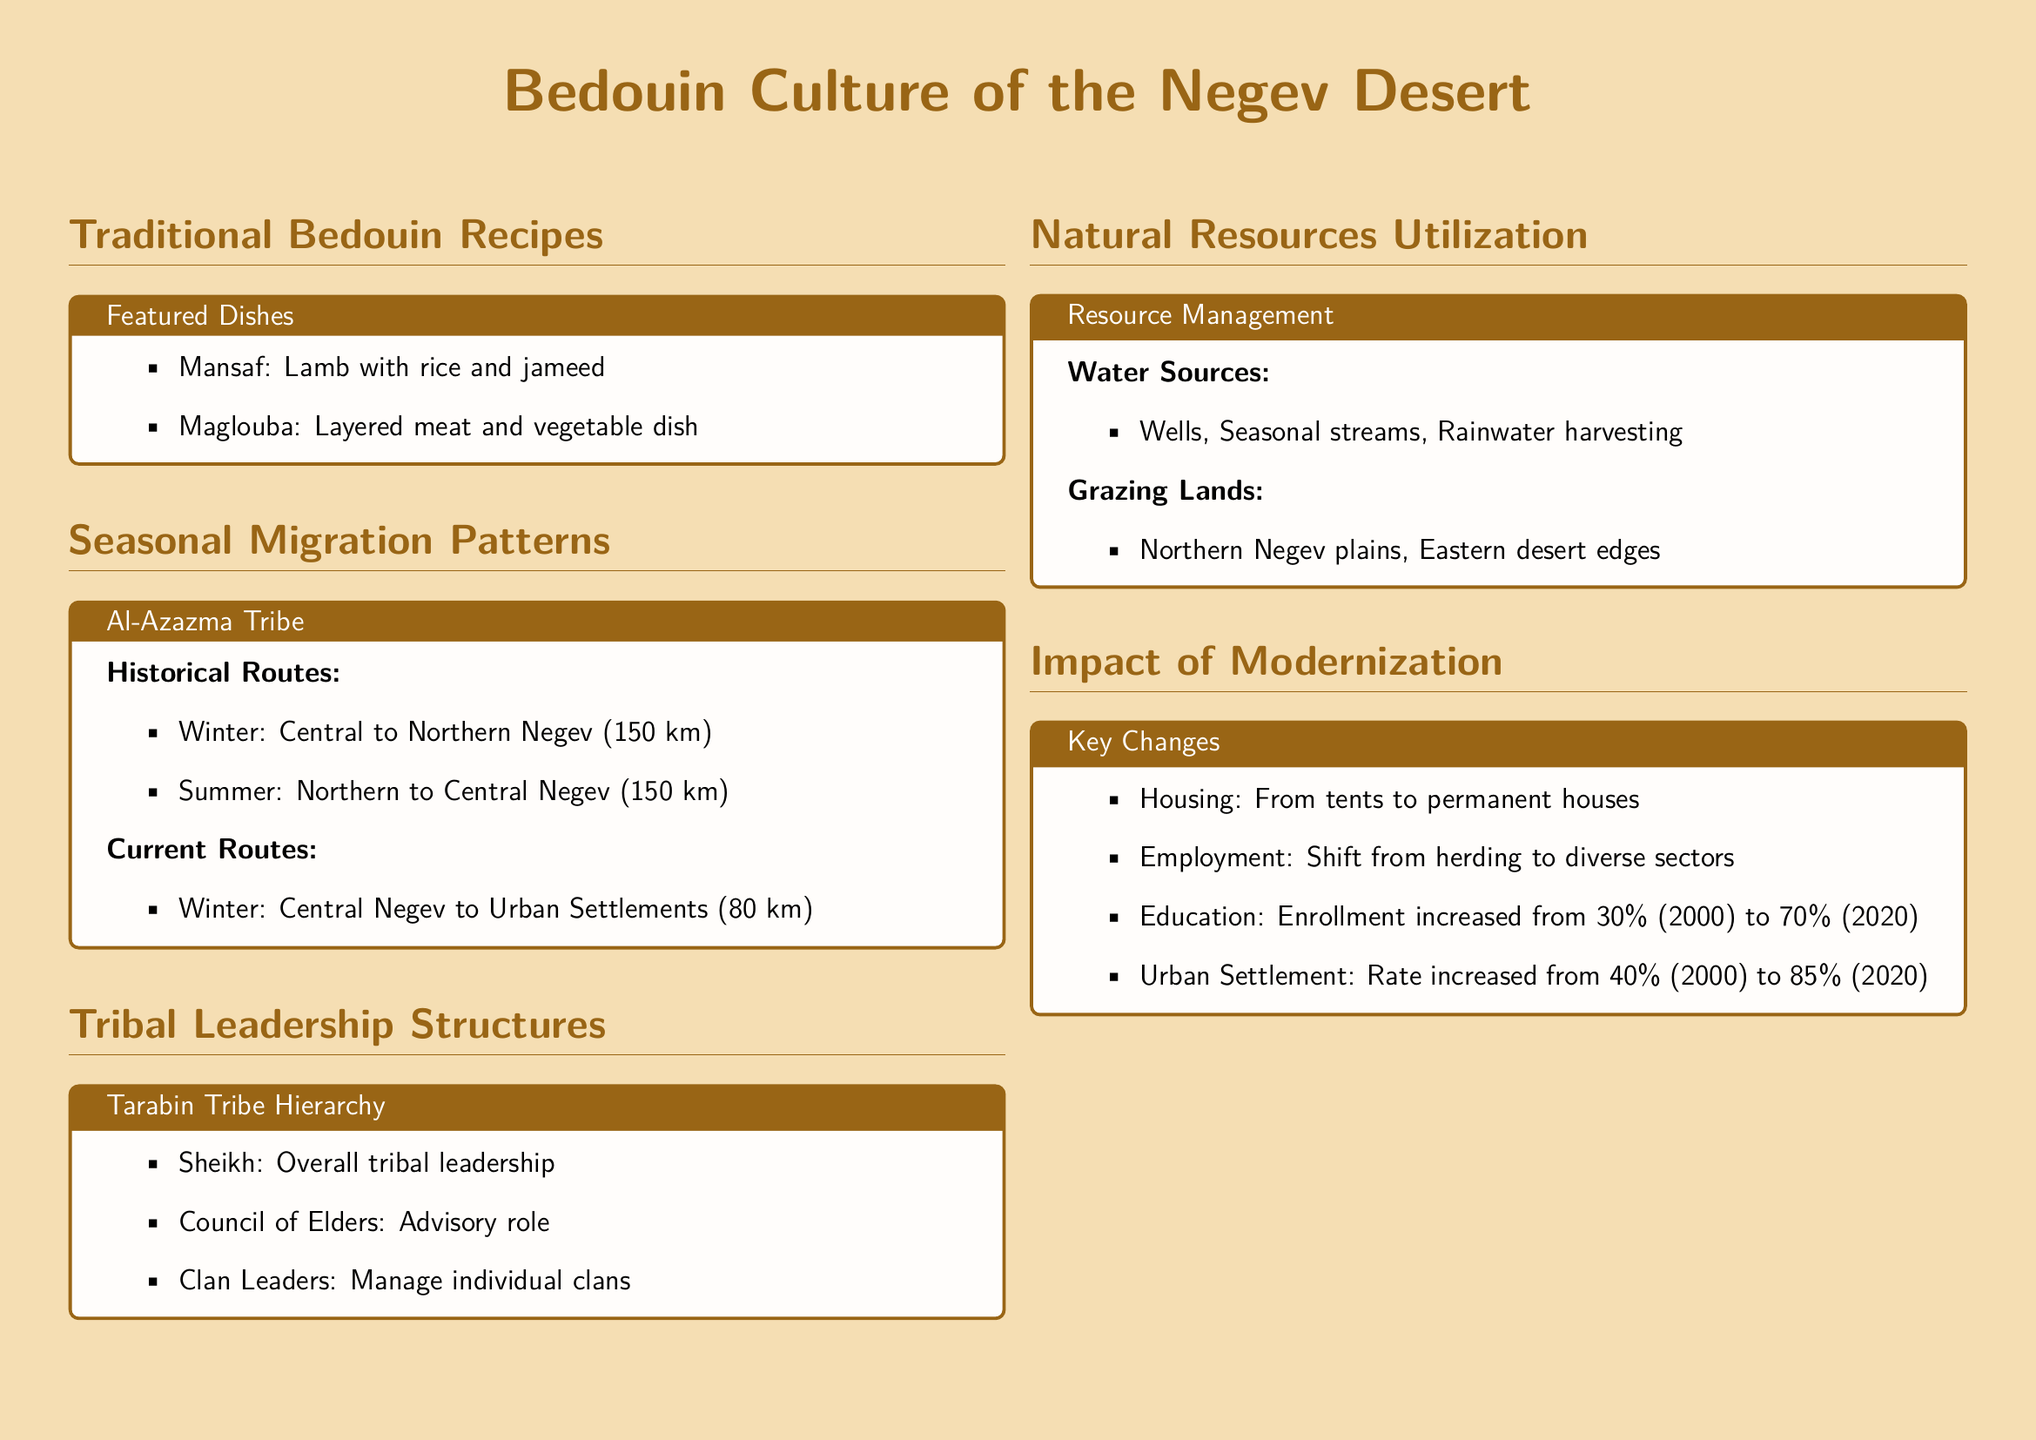What is a featured dish in traditional Bedouin recipes? The document lists "Mansaf" and "Maglouba" as featured dishes in traditional Bedouin recipes.
Answer: Mansaf What is the distance for the winter migration of the Al-Azazma tribe? The document states that the winter migration route for the Al-Azazma tribe is 150 km.
Answer: 150 km Who leads the tribal leadership structure in the Tarabin tribe? The document indicates that the Sheikh is the overall tribal leader in the Tarabin tribe.
Answer: Sheikh What is a main water source utilized in the Negev desert? According to the document, wells are one of the main water sources utilized.
Answer: Wells What was the education enrollment percentage in 2020? The document notes that the education enrollment increased to 70% in 2020.
Answer: 70% What type of housing has increased in the Bedouin lifestyle due to modernization? The document states that housing has shifted from tents to permanent houses.
Answer: Permanent houses What is one grazing land mentioned in the document? The document mentions "Northern Negev plains" as a grazing land.
Answer: Northern Negev plains What is the current migration route for the Al-Azazma tribe in winter? The document states the current winter route is from Central Negev to Urban Settlements, covering 80 km.
Answer: 80 km What role does the Council of Elders play in the tribal leadership? The document describes the Council of Elders as having an advisory role.
Answer: Advisory role 